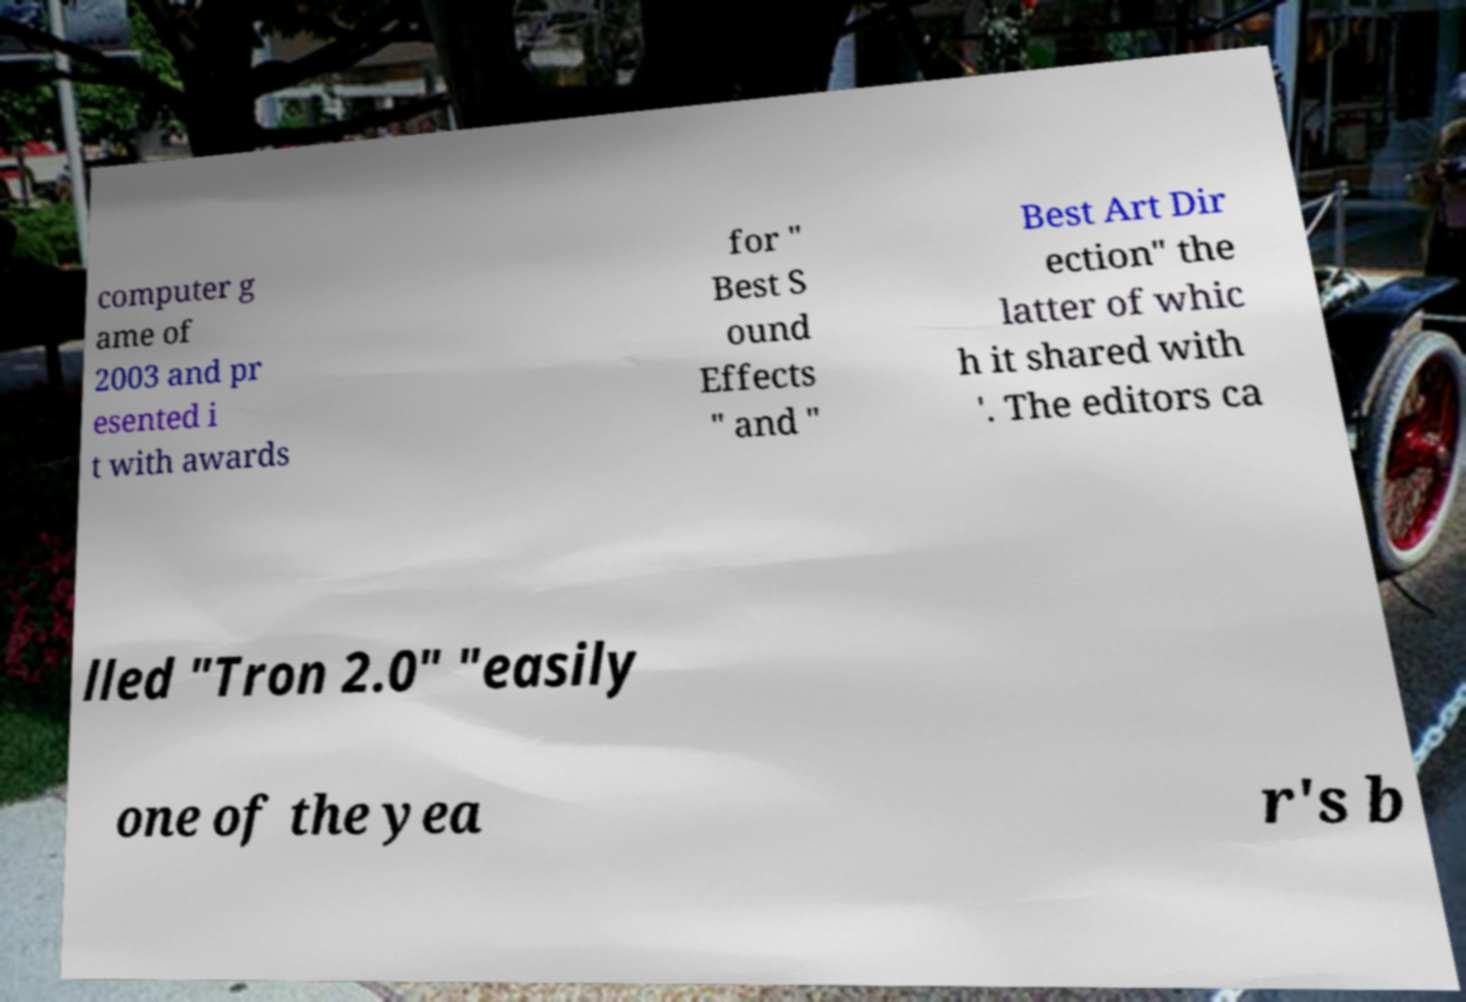Please identify and transcribe the text found in this image. computer g ame of 2003 and pr esented i t with awards for " Best S ound Effects " and " Best Art Dir ection" the latter of whic h it shared with '. The editors ca lled "Tron 2.0" "easily one of the yea r's b 